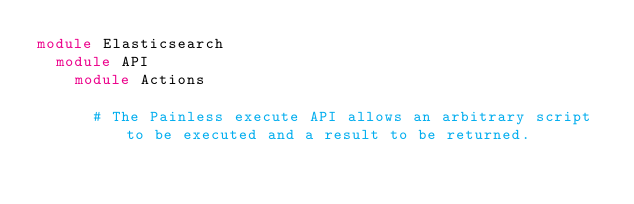<code> <loc_0><loc_0><loc_500><loc_500><_Ruby_>module Elasticsearch
  module API
    module Actions

      # The Painless execute API allows an arbitrary script to be executed and a result to be returned.</code> 